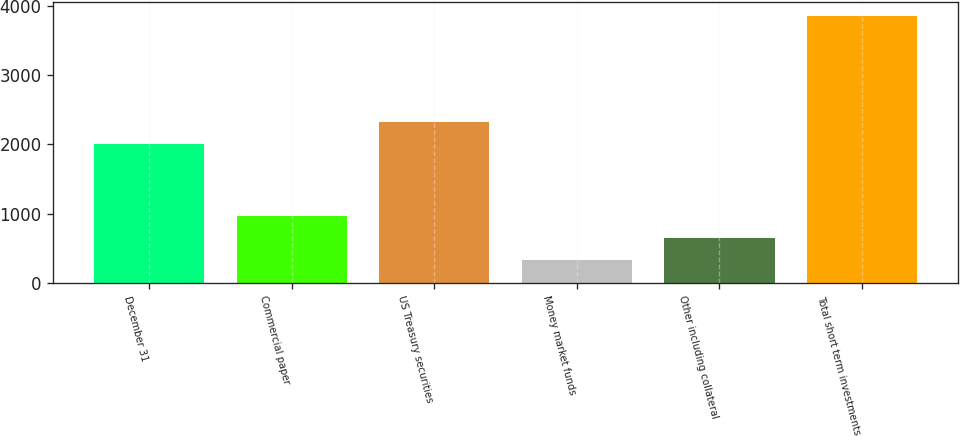<chart> <loc_0><loc_0><loc_500><loc_500><bar_chart><fcel>December 31<fcel>Commercial paper<fcel>US Treasury securities<fcel>Money market funds<fcel>Other including collateral<fcel>Total short term investments<nl><fcel>2008<fcel>970<fcel>2328.5<fcel>329<fcel>649.5<fcel>3854.5<nl></chart> 